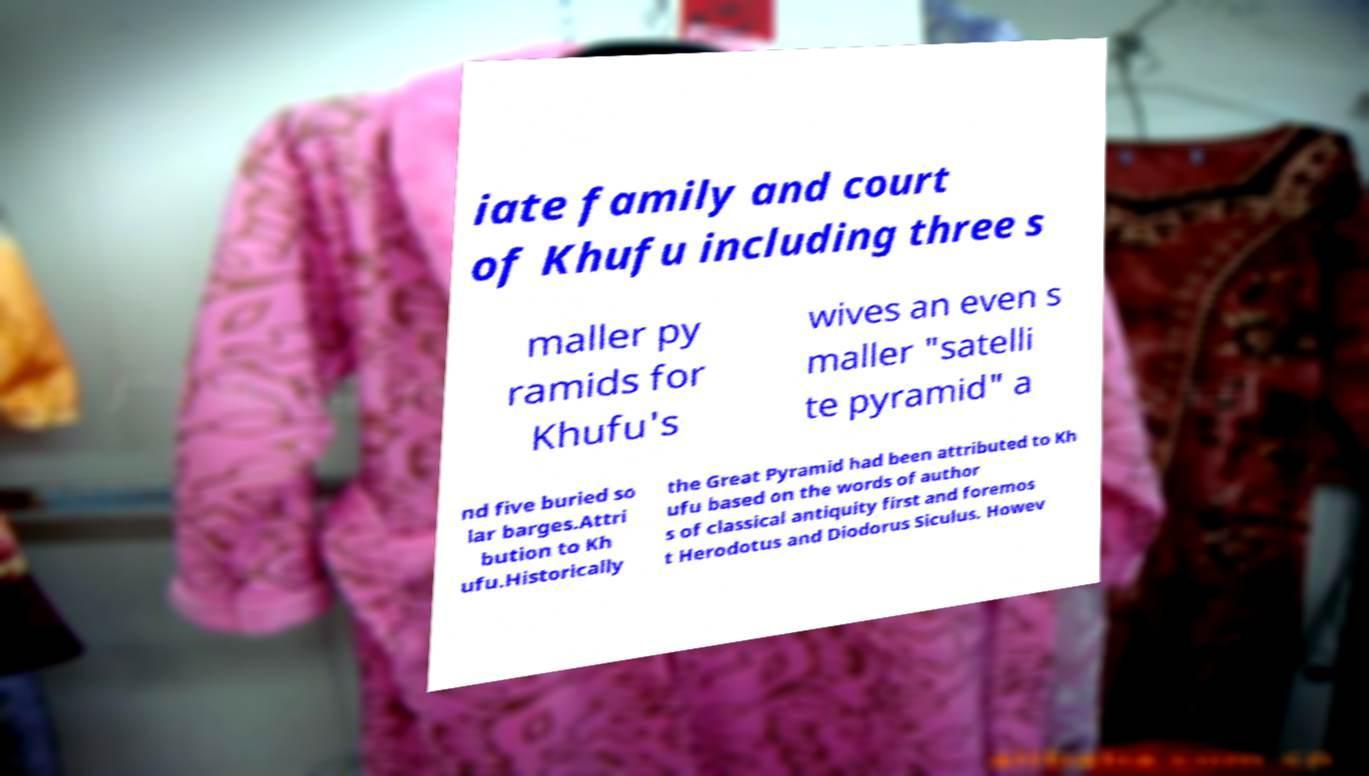Can you accurately transcribe the text from the provided image for me? iate family and court of Khufu including three s maller py ramids for Khufu's wives an even s maller "satelli te pyramid" a nd five buried so lar barges.Attri bution to Kh ufu.Historically the Great Pyramid had been attributed to Kh ufu based on the words of author s of classical antiquity first and foremos t Herodotus and Diodorus Siculus. Howev 